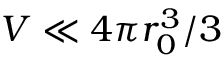Convert formula to latex. <formula><loc_0><loc_0><loc_500><loc_500>V \ll 4 \pi r _ { 0 } ^ { 3 } / 3</formula> 